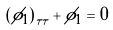Convert formula to latex. <formula><loc_0><loc_0><loc_500><loc_500>\left ( \phi _ { 1 } \right ) _ { \tau \tau } + \phi _ { 1 } = 0</formula> 